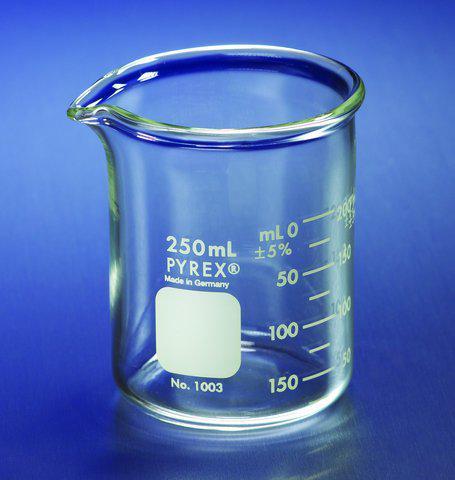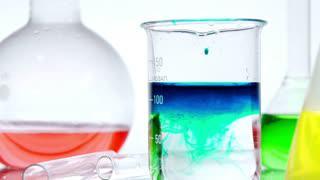The first image is the image on the left, the second image is the image on the right. Evaluate the accuracy of this statement regarding the images: "An image shows beakers containing multiple liquid colors, including red, yellow, and blue.". Is it true? Answer yes or no. Yes. 